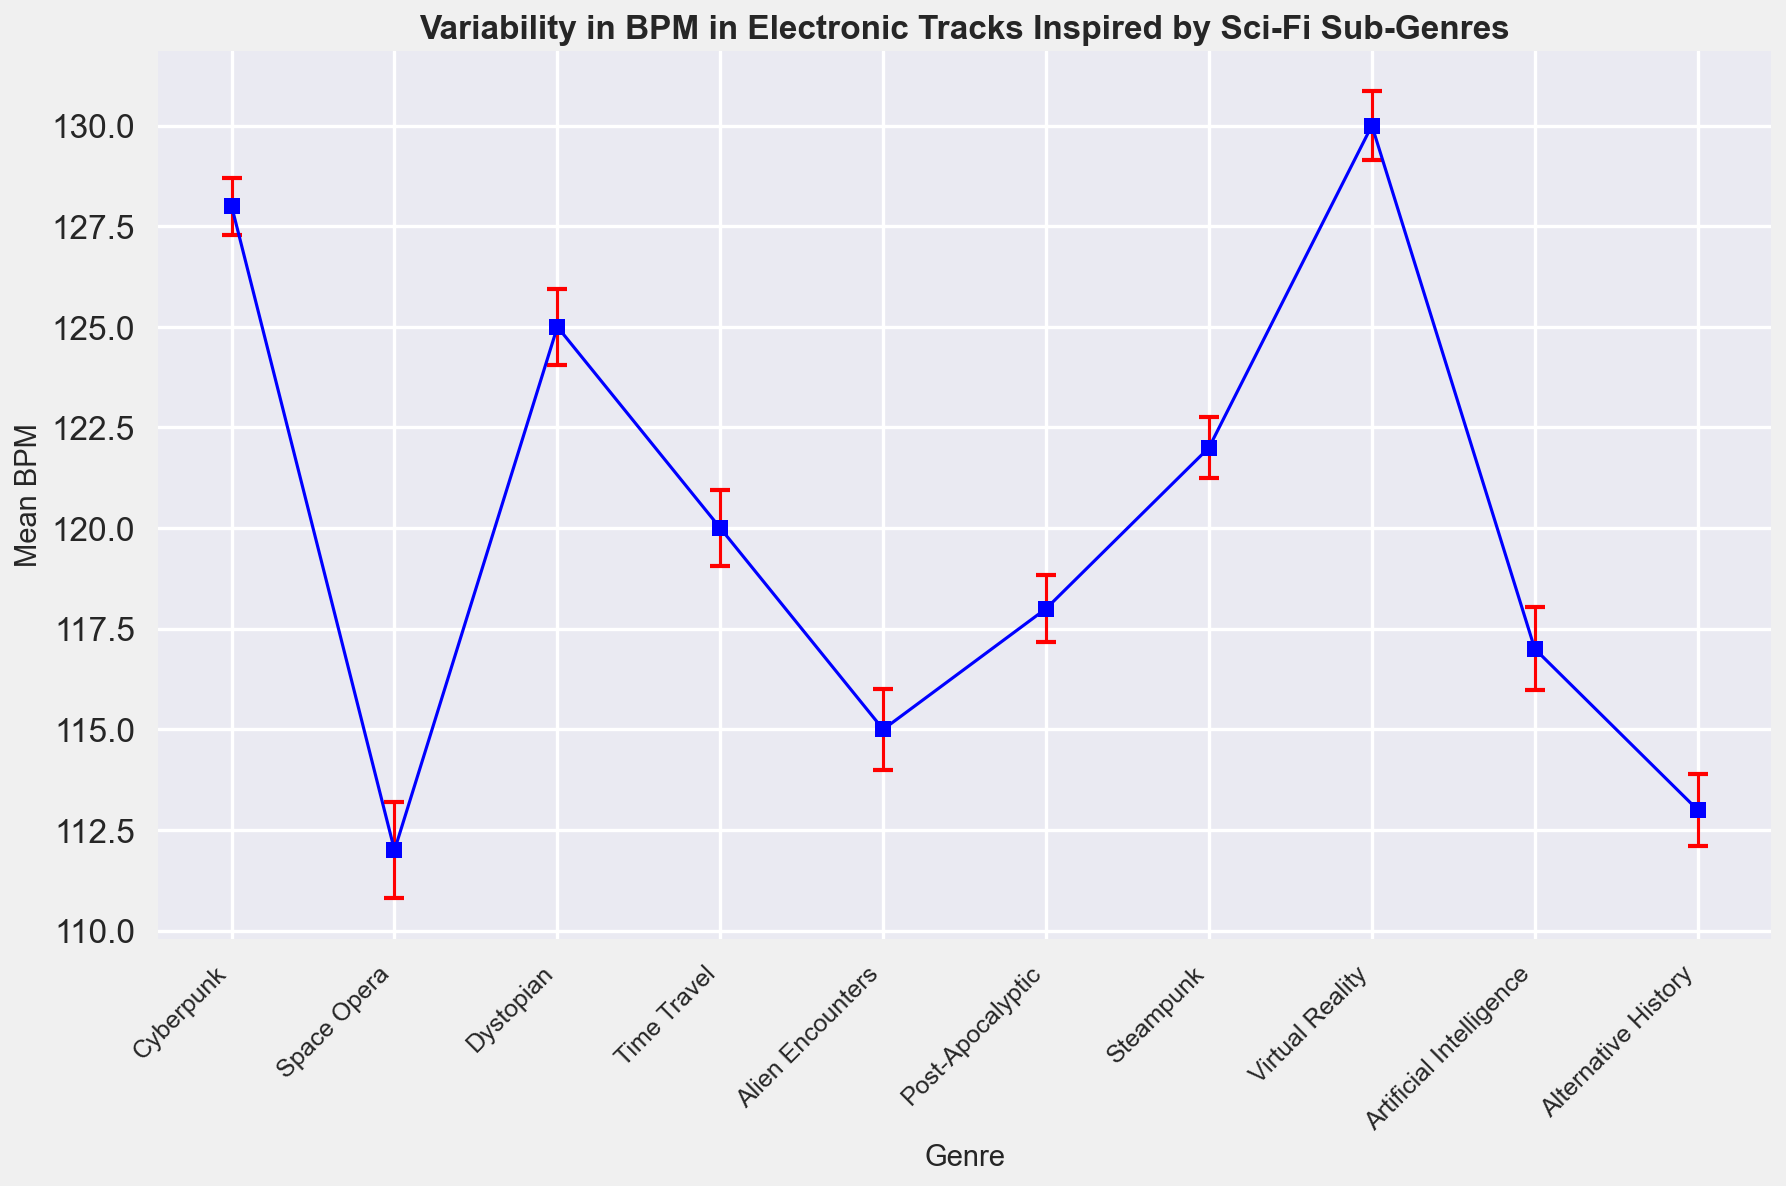Which sub-genre has the highest mean BPM? By examining the height of the plotted points, we see that 'Virtual Reality' has the highest mean BPM value.
Answer: Virtual Reality What is the difference in mean BPM between the sub-genres with the highest and lowest values? 'Virtual Reality' has the highest mean BPM at 130, and 'Space Opera' has the lowest at 112. The difference is 130 - 112.
Answer: 18 Which sub-genre has the largest error margin? The error bars represent the error margin. By comparing the lengths of the error bars, 'Space Opera' has the largest error margin.
Answer: Space Opera How does the mean BPM of 'Cyberpunk' compare to 'Dystopian'? 'Cyberpunk' has a mean BPM of 128, while 'Dystopian' has a mean BPM of 125. Therefore, 'Cyberpunk' is greater.
Answer: Cyberpunk is higher Which sub-genres have nearly the same mean BPM? By comparing the heights of the plotted points, 'Time Travel' and 'Post-Apocalyptic' both have mean BPM values close to 120 and 118 respectively.
Answer: Time Travel and Post-Apocalyptic What’s the mean of the mean BPMs for 'Steampunk' and 'Artificial Intelligence'? 'Steampunk' has a mean BPM of 122 and 'Artificial Intelligence' has a mean BPM of 117. Their mean is (122 + 117) / 2 = 119.5
Answer: 119.5 Which sub-genre has the smallest standard deviation, hence the smallest error bars? The lengths of the error bars represent the standard deviation. 'Steampunk' and 'Cyberpunk' have the smallest error bars, with 'Steampunk' having a slightly smaller standard deviation.
Answer: Steampunk How does the sample size affect the error margin for 'Alien Encounters'? 'Alien Encounters' has a sample size of 48 and a standard deviation of 7. The error margin is calculated using std/sqrt(sample size), showing the effect of sample size.
Answer: Smaller sample size increases error margin 